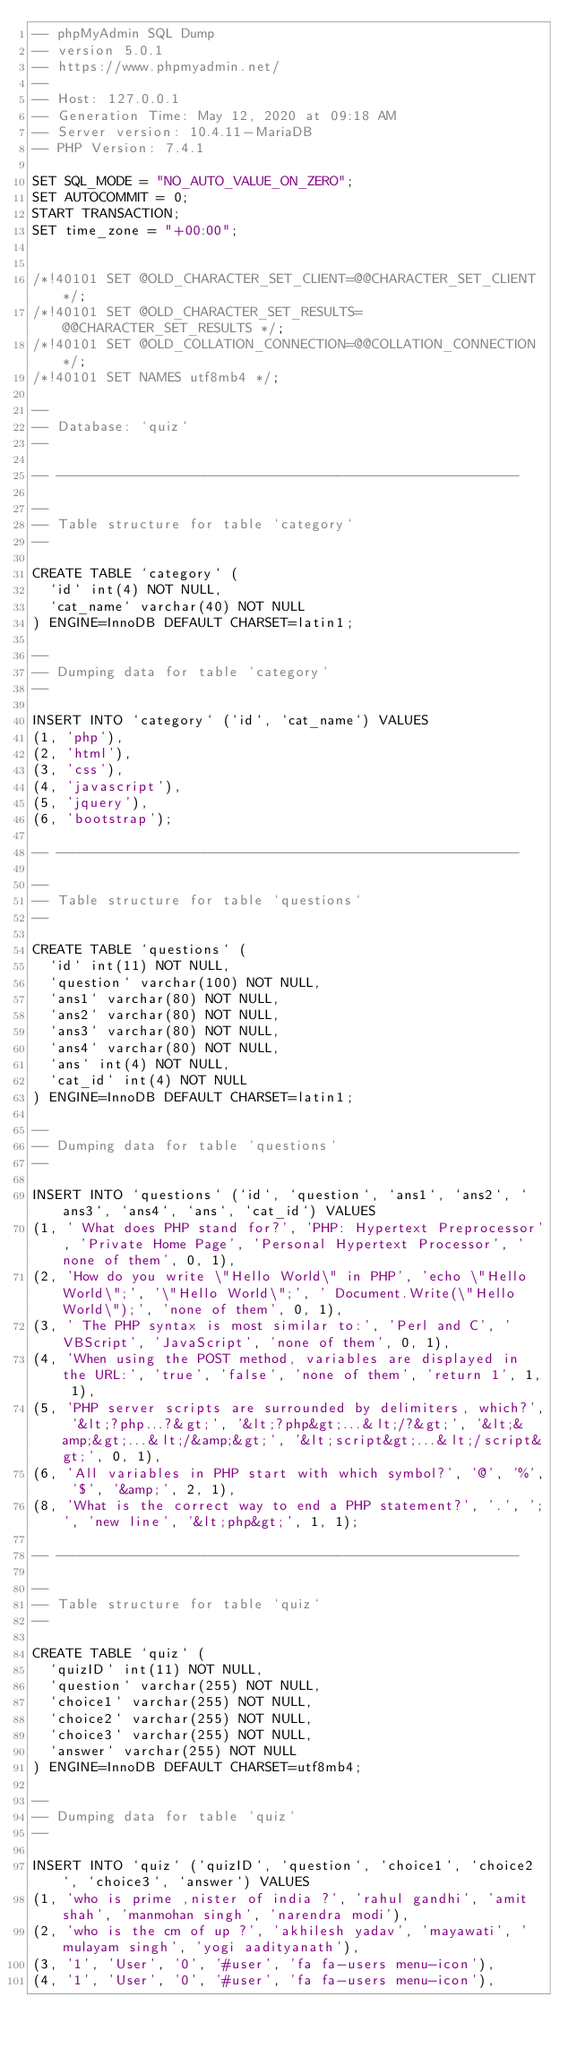<code> <loc_0><loc_0><loc_500><loc_500><_SQL_>-- phpMyAdmin SQL Dump
-- version 5.0.1
-- https://www.phpmyadmin.net/
--
-- Host: 127.0.0.1
-- Generation Time: May 12, 2020 at 09:18 AM
-- Server version: 10.4.11-MariaDB
-- PHP Version: 7.4.1

SET SQL_MODE = "NO_AUTO_VALUE_ON_ZERO";
SET AUTOCOMMIT = 0;
START TRANSACTION;
SET time_zone = "+00:00";


/*!40101 SET @OLD_CHARACTER_SET_CLIENT=@@CHARACTER_SET_CLIENT */;
/*!40101 SET @OLD_CHARACTER_SET_RESULTS=@@CHARACTER_SET_RESULTS */;
/*!40101 SET @OLD_COLLATION_CONNECTION=@@COLLATION_CONNECTION */;
/*!40101 SET NAMES utf8mb4 */;

--
-- Database: `quiz`
--

-- --------------------------------------------------------

--
-- Table structure for table `category`
--

CREATE TABLE `category` (
  `id` int(4) NOT NULL,
  `cat_name` varchar(40) NOT NULL
) ENGINE=InnoDB DEFAULT CHARSET=latin1;

--
-- Dumping data for table `category`
--

INSERT INTO `category` (`id`, `cat_name`) VALUES
(1, 'php'),
(2, 'html'),
(3, 'css'),
(4, 'javascript'),
(5, 'jquery'),
(6, 'bootstrap');

-- --------------------------------------------------------

--
-- Table structure for table `questions`
--

CREATE TABLE `questions` (
  `id` int(11) NOT NULL,
  `question` varchar(100) NOT NULL,
  `ans1` varchar(80) NOT NULL,
  `ans2` varchar(80) NOT NULL,
  `ans3` varchar(80) NOT NULL,
  `ans4` varchar(80) NOT NULL,
  `ans` int(4) NOT NULL,
  `cat_id` int(4) NOT NULL
) ENGINE=InnoDB DEFAULT CHARSET=latin1;

--
-- Dumping data for table `questions`
--

INSERT INTO `questions` (`id`, `question`, `ans1`, `ans2`, `ans3`, `ans4`, `ans`, `cat_id`) VALUES
(1, ' What does PHP stand for?', 'PHP: Hypertext Preprocessor', 'Private Home Page', 'Personal Hypertext Processor', 'none of them', 0, 1),
(2, 'How do you write \"Hello World\" in PHP', 'echo \"Hello World\";', '\"Hello World\";', ' Document.Write(\"Hello World\");', 'none of them', 0, 1),
(3, ' The PHP syntax is most similar to:', 'Perl and C', 'VBScript', 'JavaScript', 'none of them', 0, 1),
(4, 'When using the POST method, variables are displayed in the URL:', 'true', 'false', 'none of them', 'return 1', 1, 1),
(5, 'PHP server scripts are surrounded by delimiters, which?', '&lt;?php...?&gt;', '&lt;?php&gt;...&lt;/?&gt;', '&lt;&amp;&gt;...&lt;/&amp;&gt;', '&lt;script&gt;...&lt;/script&gt;', 0, 1),
(6, 'All variables in PHP start with which symbol?', '@', '%', '$', '&amp;', 2, 1),
(8, 'What is the correct way to end a PHP statement?', '.', ';', 'new line', '&lt;php&gt;', 1, 1);

-- --------------------------------------------------------

--
-- Table structure for table `quiz`
--

CREATE TABLE `quiz` (
  `quizID` int(11) NOT NULL,
  `question` varchar(255) NOT NULL,
  `choice1` varchar(255) NOT NULL,
  `choice2` varchar(255) NOT NULL,
  `choice3` varchar(255) NOT NULL,
  `answer` varchar(255) NOT NULL
) ENGINE=InnoDB DEFAULT CHARSET=utf8mb4;

--
-- Dumping data for table `quiz`
--

INSERT INTO `quiz` (`quizID`, `question`, `choice1`, `choice2`, `choice3`, `answer`) VALUES
(1, 'who is prime ,nister of india ?', 'rahul gandhi', 'amit shah', 'manmohan singh', 'narendra modi'),
(2, 'who is the cm of up ?', 'akhilesh yadav', 'mayawati', 'mulayam singh', 'yogi aadityanath'),
(3, '1', 'User', '0', '#user', 'fa fa-users menu-icon'),
(4, '1', 'User', '0', '#user', 'fa fa-users menu-icon'),</code> 